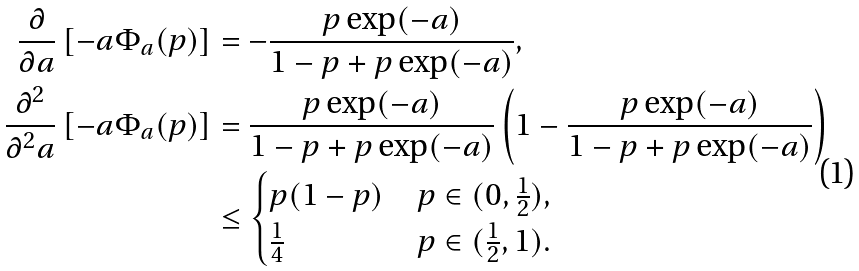<formula> <loc_0><loc_0><loc_500><loc_500>\frac { \partial } { \partial a } \left [ - a \Phi _ { a } ( p ) \right ] & = - \frac { p \exp ( - a ) } { 1 - p + p \exp ( - a ) } , \\ \frac { \partial ^ { 2 } } { \partial ^ { 2 } a } \left [ - a \Phi _ { a } ( p ) \right ] & = \frac { p \exp ( - a ) } { 1 - p + p \exp ( - a ) } \left ( 1 - \frac { p \exp ( - a ) } { 1 - p + p \exp ( - a ) } \right ) \\ & \leq \begin{cases} p ( 1 - p ) & p \in ( 0 , \frac { 1 } { 2 } ) , \\ \frac { 1 } { 4 } & p \in ( \frac { 1 } { 2 } , 1 ) . \end{cases}</formula> 